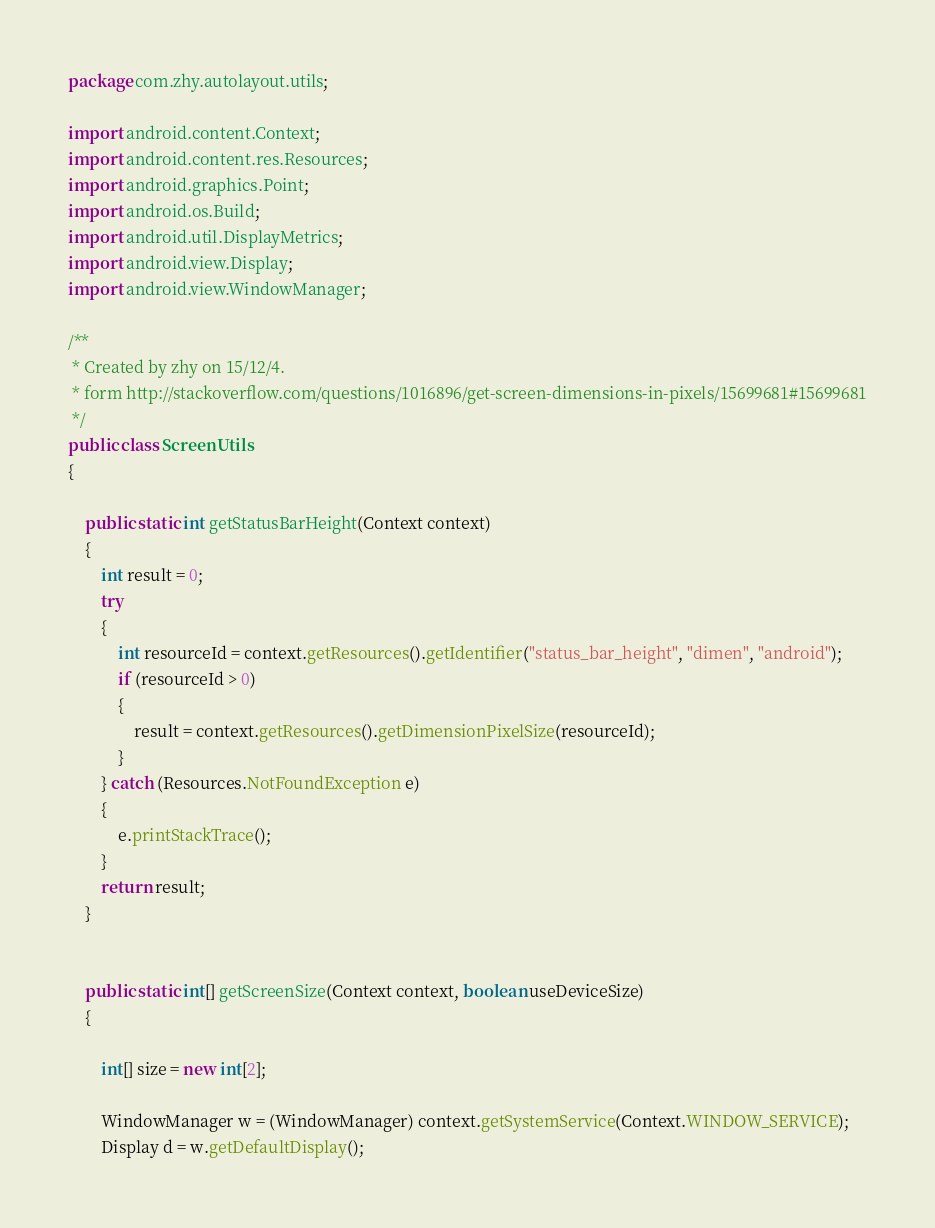<code> <loc_0><loc_0><loc_500><loc_500><_Java_>package com.zhy.autolayout.utils;

import android.content.Context;
import android.content.res.Resources;
import android.graphics.Point;
import android.os.Build;
import android.util.DisplayMetrics;
import android.view.Display;
import android.view.WindowManager;

/**
 * Created by zhy on 15/12/4.
 * form http://stackoverflow.com/questions/1016896/get-screen-dimensions-in-pixels/15699681#15699681
 */
public class ScreenUtils
{

    public static int getStatusBarHeight(Context context)
    {
        int result = 0;
        try
        {
            int resourceId = context.getResources().getIdentifier("status_bar_height", "dimen", "android");
            if (resourceId > 0)
            {
                result = context.getResources().getDimensionPixelSize(resourceId);
            }
        } catch (Resources.NotFoundException e)
        {
            e.printStackTrace();
        }
        return result;
    }


    public static int[] getScreenSize(Context context, boolean useDeviceSize)
    {

        int[] size = new int[2];

        WindowManager w = (WindowManager) context.getSystemService(Context.WINDOW_SERVICE);
        Display d = w.getDefaultDisplay();</code> 